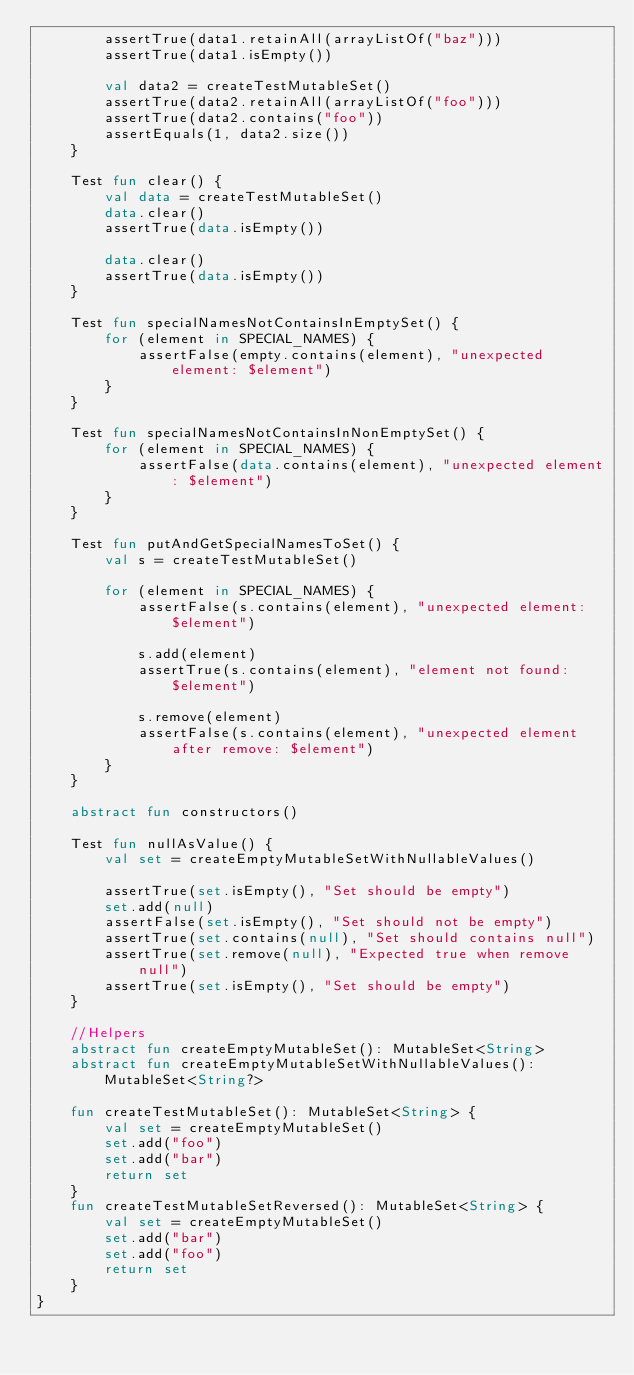<code> <loc_0><loc_0><loc_500><loc_500><_Kotlin_>        assertTrue(data1.retainAll(arrayListOf("baz")))
        assertTrue(data1.isEmpty())

        val data2 = createTestMutableSet()
        assertTrue(data2.retainAll(arrayListOf("foo")))
        assertTrue(data2.contains("foo"))
        assertEquals(1, data2.size())
    }

    Test fun clear() {
        val data = createTestMutableSet()
        data.clear()
        assertTrue(data.isEmpty())

        data.clear()
        assertTrue(data.isEmpty())
    }

    Test fun specialNamesNotContainsInEmptySet() {
        for (element in SPECIAL_NAMES) {
            assertFalse(empty.contains(element), "unexpected element: $element")
        }
    }

    Test fun specialNamesNotContainsInNonEmptySet() {
        for (element in SPECIAL_NAMES) {
            assertFalse(data.contains(element), "unexpected element: $element")
        }
    }

    Test fun putAndGetSpecialNamesToSet() {
        val s = createTestMutableSet()

        for (element in SPECIAL_NAMES) {
            assertFalse(s.contains(element), "unexpected element: $element")

            s.add(element)
            assertTrue(s.contains(element), "element not found: $element")

            s.remove(element)
            assertFalse(s.contains(element), "unexpected element after remove: $element")
        }
    }

    abstract fun constructors()

    Test fun nullAsValue() {
        val set = createEmptyMutableSetWithNullableValues()

        assertTrue(set.isEmpty(), "Set should be empty")
        set.add(null)
        assertFalse(set.isEmpty(), "Set should not be empty")
        assertTrue(set.contains(null), "Set should contains null")
        assertTrue(set.remove(null), "Expected true when remove null")
        assertTrue(set.isEmpty(), "Set should be empty")
    }

    //Helpers
    abstract fun createEmptyMutableSet(): MutableSet<String>
    abstract fun createEmptyMutableSetWithNullableValues(): MutableSet<String?>

    fun createTestMutableSet(): MutableSet<String> {
        val set = createEmptyMutableSet()
        set.add("foo")
        set.add("bar")
        return set
    }
    fun createTestMutableSetReversed(): MutableSet<String> {
        val set = createEmptyMutableSet()
        set.add("bar")
        set.add("foo")
        return set
    }
}
</code> 